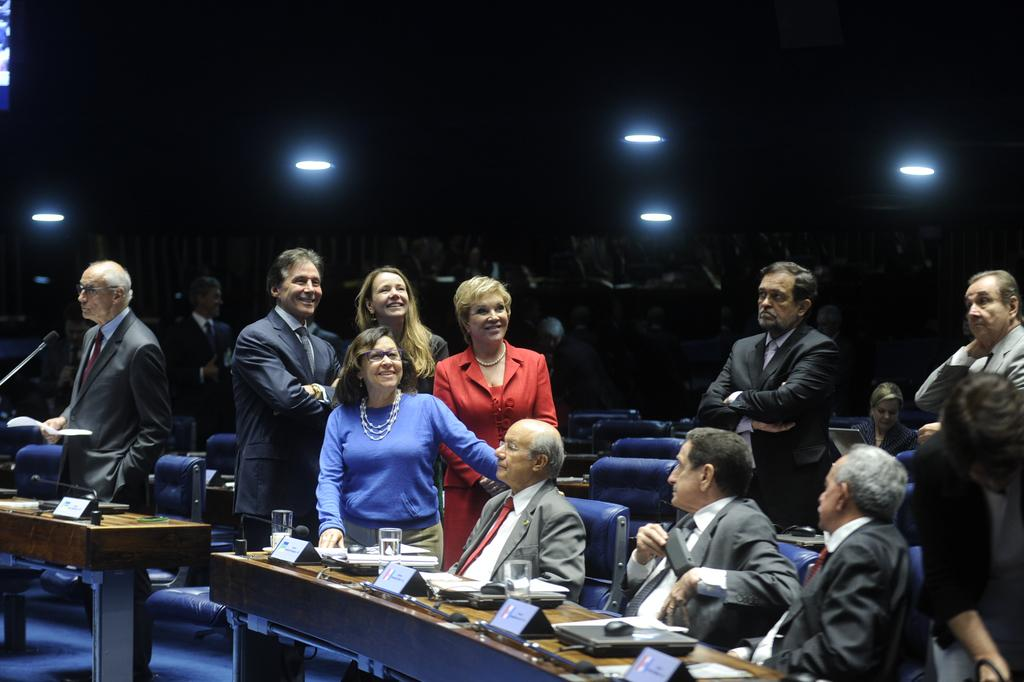How many people are in the image? There are people in the image, but the exact number is not specified. What are some of the people doing in the image? Some people are sitting on chairs in the image. What is on the table in the image? There is a table in the image with name boards and glasses on it. What can be seen in the image that provides illumination? There are lights in the image. What is the purpose of the balance in the image? There is no balance present in the image. 